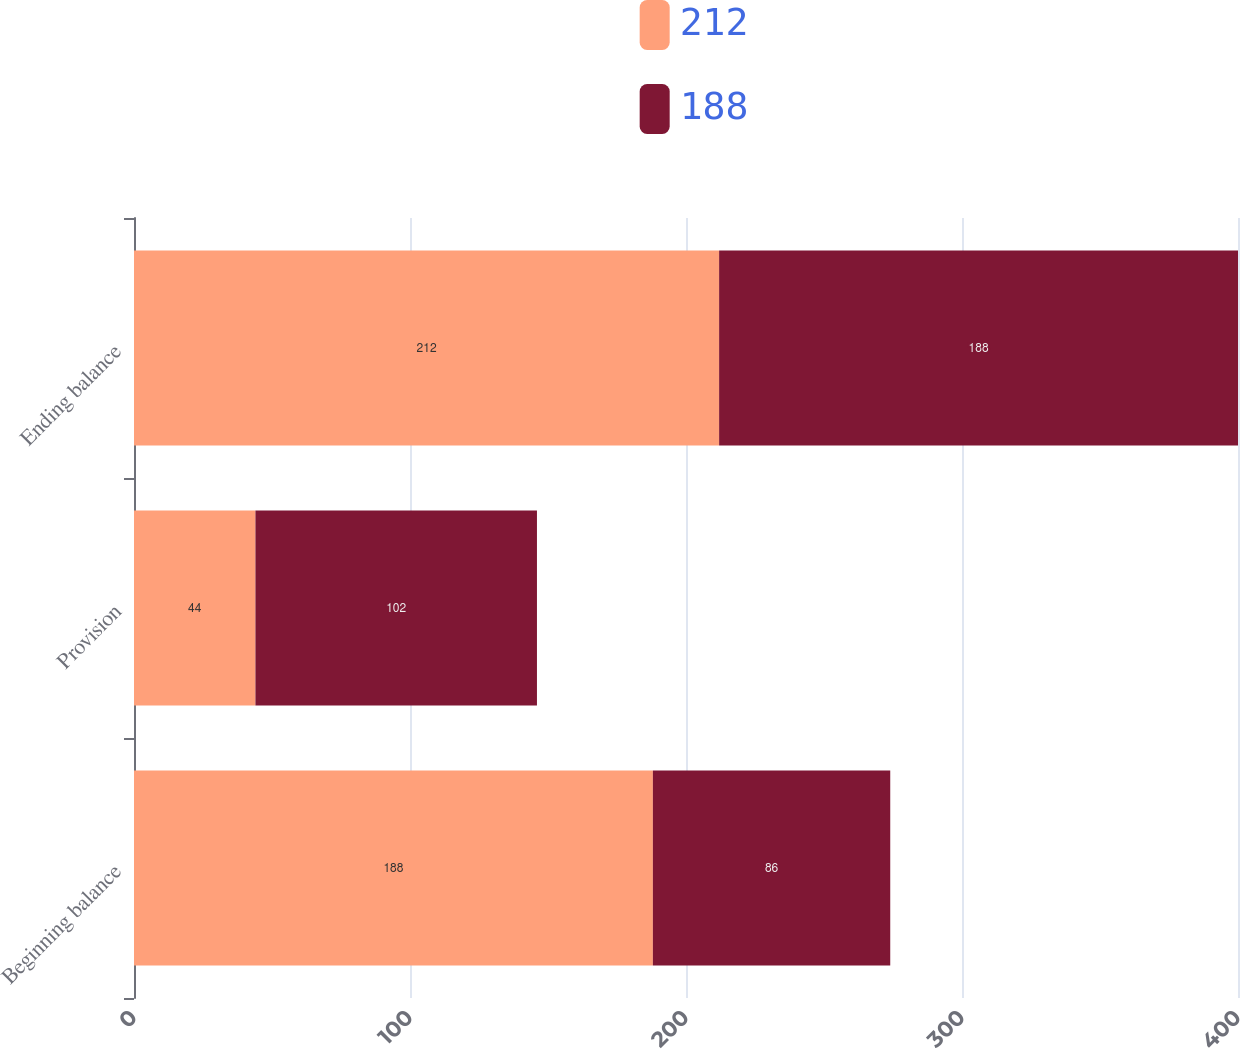Convert chart. <chart><loc_0><loc_0><loc_500><loc_500><stacked_bar_chart><ecel><fcel>Beginning balance<fcel>Provision<fcel>Ending balance<nl><fcel>212<fcel>188<fcel>44<fcel>212<nl><fcel>188<fcel>86<fcel>102<fcel>188<nl></chart> 